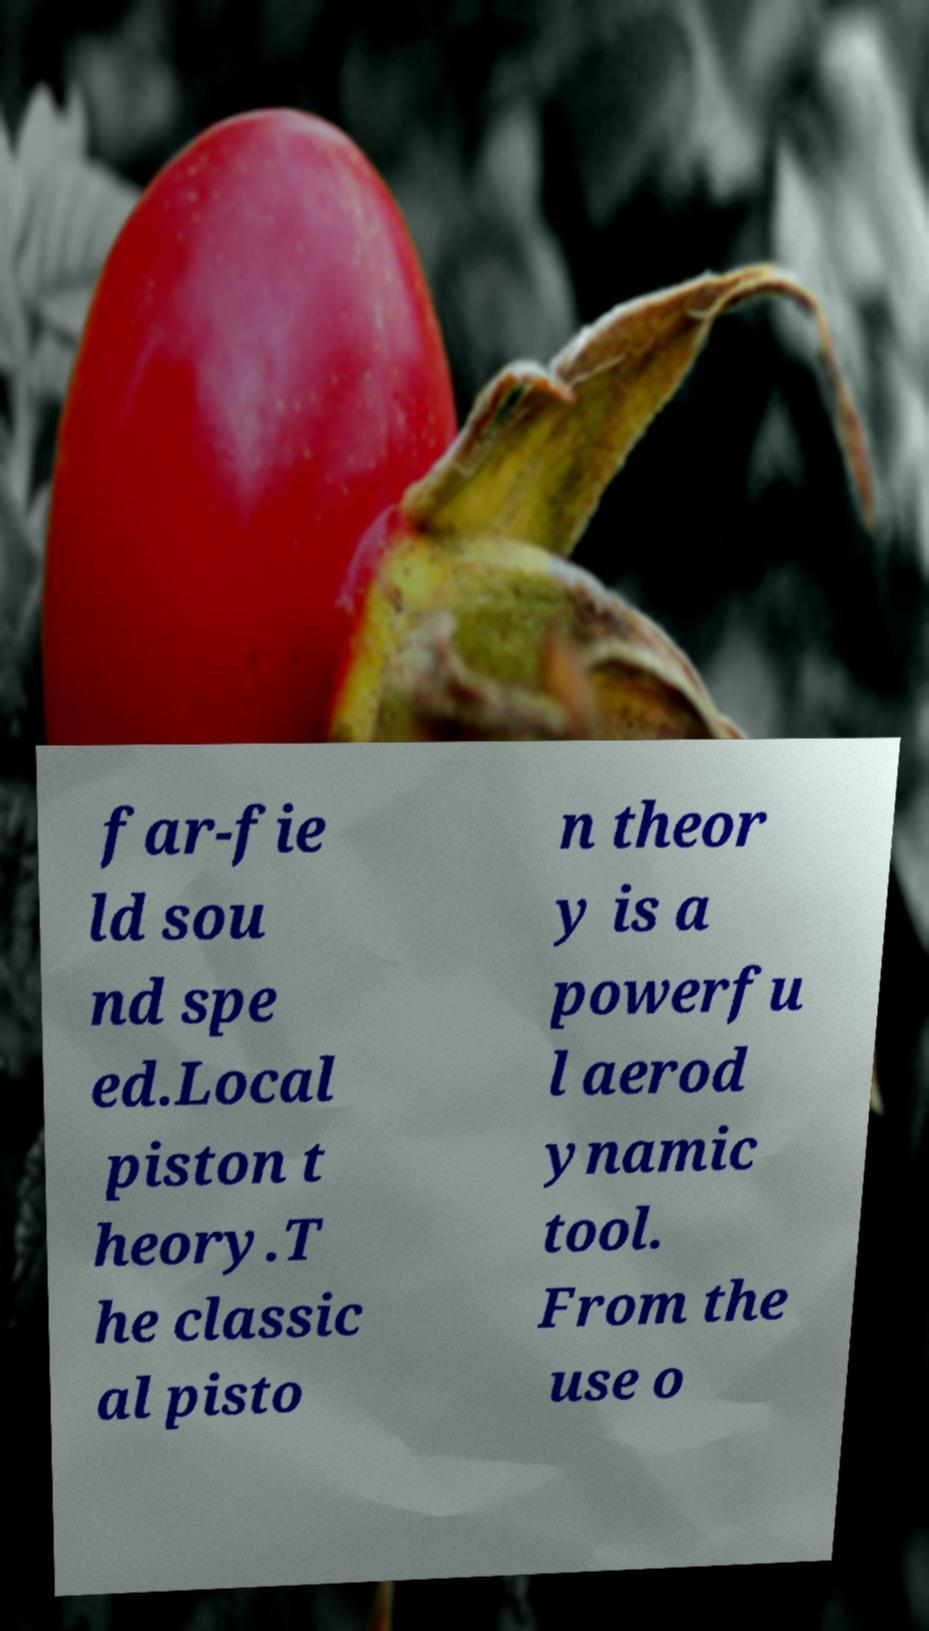I need the written content from this picture converted into text. Can you do that? far-fie ld sou nd spe ed.Local piston t heory.T he classic al pisto n theor y is a powerfu l aerod ynamic tool. From the use o 